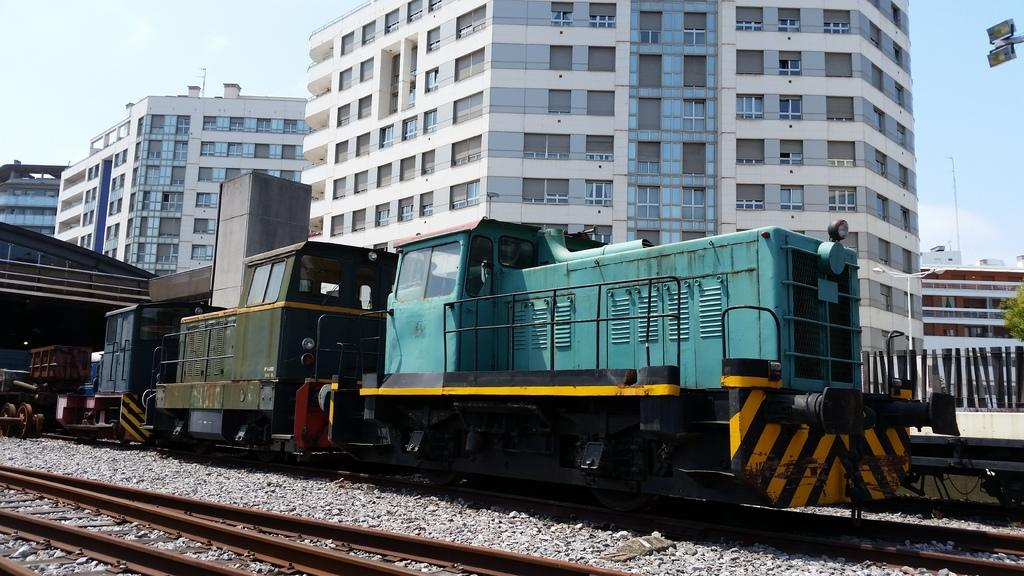What is the main subject of the image? The main subject of the image is a train. Where is the train located in the image? The train is on a railway track. What can be seen in the background of the image? There are tall buildings behind the train. What feature do the tall buildings have? The tall buildings have a lot of windows. What type of produce can be seen growing near the train in the image? There is no produce visible in the image; it features a train on a railway track with tall buildings in the background. Can you tell me the price of the train in the image? There is no receipt or price mentioned in the image, which only shows a train on a railway track with tall buildings in the background. 